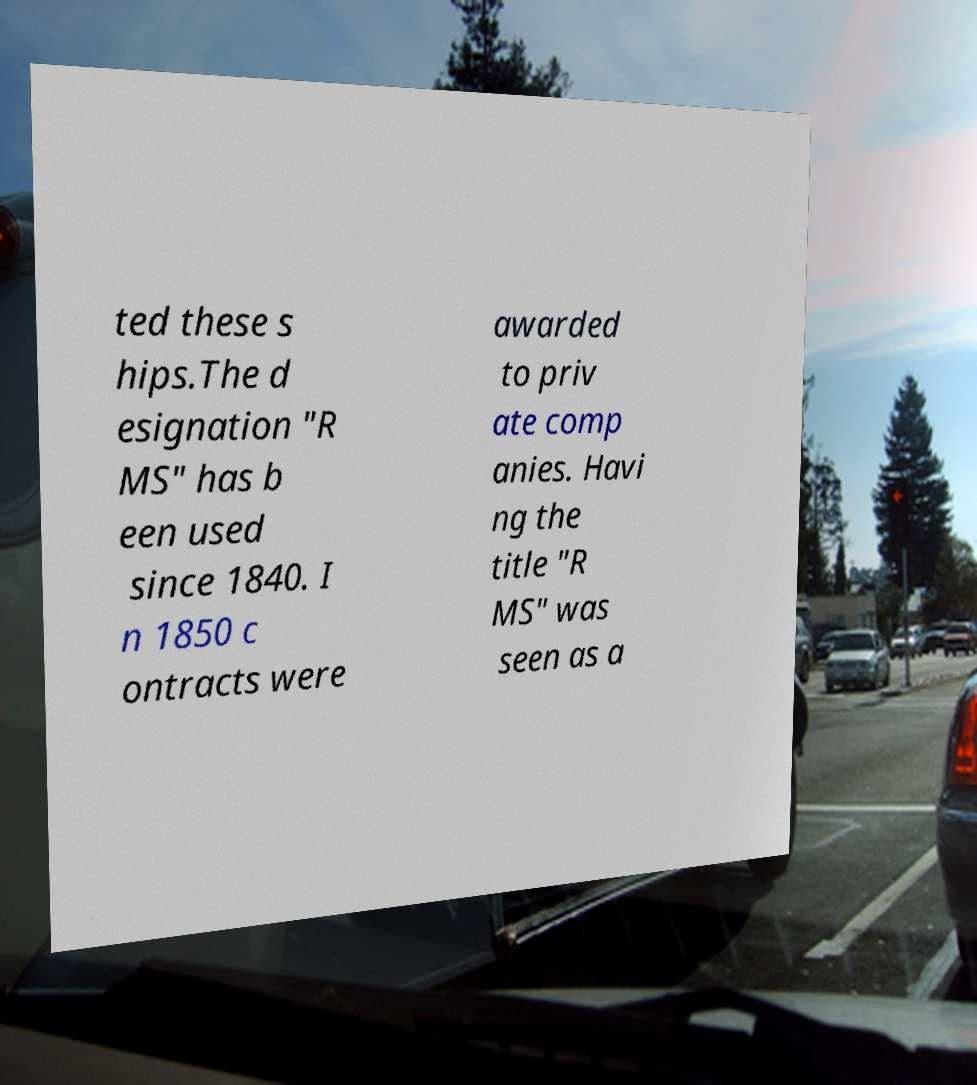Please identify and transcribe the text found in this image. ted these s hips.The d esignation "R MS" has b een used since 1840. I n 1850 c ontracts were awarded to priv ate comp anies. Havi ng the title "R MS" was seen as a 